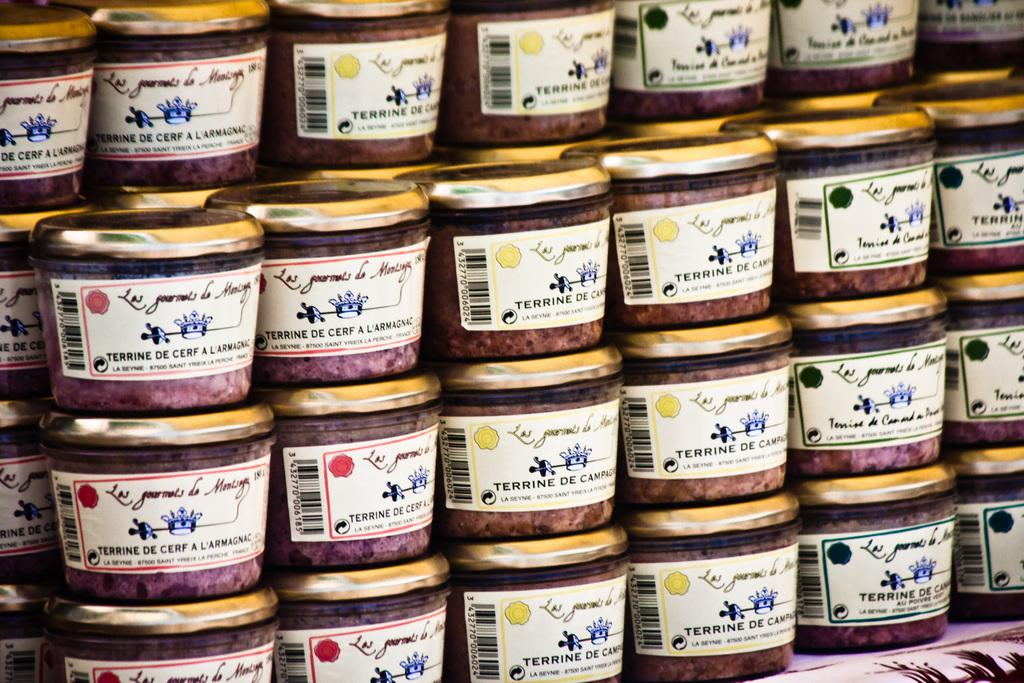<image>
Share a concise interpretation of the image provided. Jars with the label Terrine De Cerf A'Larmagnac are stacked. 